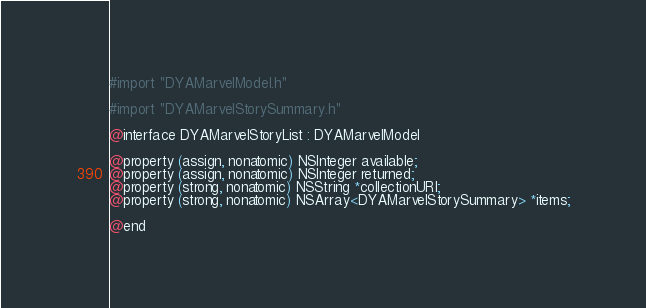<code> <loc_0><loc_0><loc_500><loc_500><_C_>#import "DYAMarvelModel.h"

#import "DYAMarvelStorySummary.h"

@interface DYAMarvelStoryList : DYAMarvelModel

@property (assign, nonatomic) NSInteger available;
@property (assign, nonatomic) NSInteger returned;
@property (strong, nonatomic) NSString *collectionURI;
@property (strong, nonatomic) NSArray<DYAMarvelStorySummary> *items;

@end
</code> 